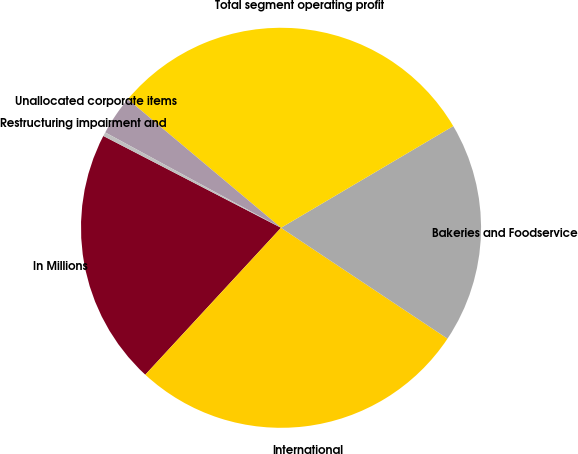<chart> <loc_0><loc_0><loc_500><loc_500><pie_chart><fcel>In Millions<fcel>International<fcel>Bakeries and Foodservice<fcel>Total segment operating profit<fcel>Unallocated corporate items<fcel>Restructuring impairment and<nl><fcel>20.72%<fcel>27.52%<fcel>17.84%<fcel>30.4%<fcel>3.2%<fcel>0.32%<nl></chart> 